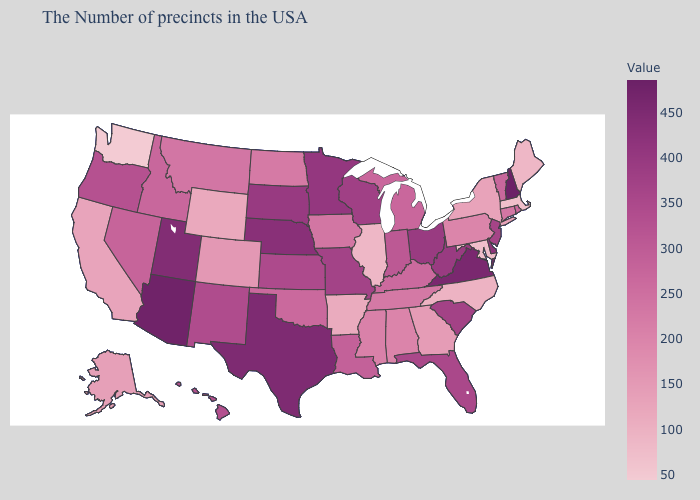Does Colorado have the lowest value in the USA?
Write a very short answer. No. Among the states that border Kansas , which have the highest value?
Quick response, please. Nebraska. Is the legend a continuous bar?
Write a very short answer. Yes. Does Montana have the highest value in the West?
Be succinct. No. Among the states that border New Hampshire , does Massachusetts have the highest value?
Concise answer only. No. Does New York have the highest value in the Northeast?
Answer briefly. No. 